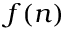<formula> <loc_0><loc_0><loc_500><loc_500>f ( n )</formula> 